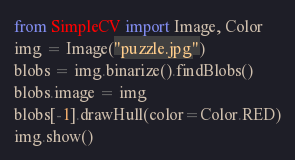Convert code to text. <code><loc_0><loc_0><loc_500><loc_500><_Python_>from SimpleCV import Image, Color
img = Image("puzzle.jpg")
blobs = img.binarize().findBlobs()
blobs.image = img
blobs[-1].drawHull(color=Color.RED)
img.show()</code> 